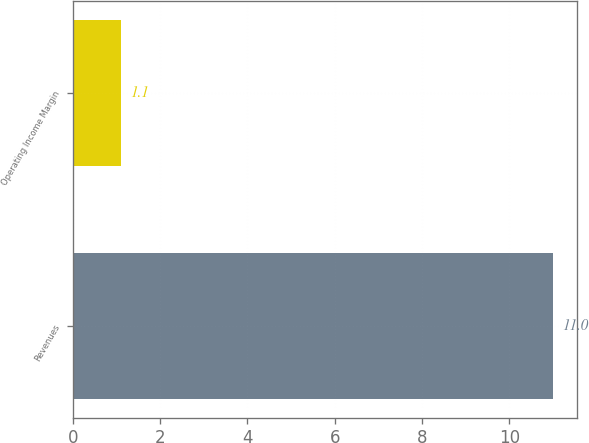Convert chart to OTSL. <chart><loc_0><loc_0><loc_500><loc_500><bar_chart><fcel>Revenues<fcel>Operating Income Margin<nl><fcel>11<fcel>1.1<nl></chart> 